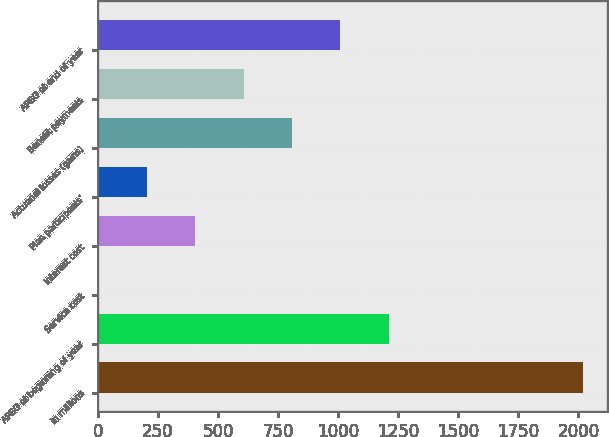<chart> <loc_0><loc_0><loc_500><loc_500><bar_chart><fcel>in millions<fcel>APBO at beginning of year<fcel>Service cost<fcel>Interest cost<fcel>Plan participants'<fcel>Actuarial losses (gains)<fcel>Benefit payments<fcel>APBO at end of year<nl><fcel>2018<fcel>1211.2<fcel>1<fcel>404.4<fcel>202.7<fcel>807.8<fcel>606.1<fcel>1009.5<nl></chart> 